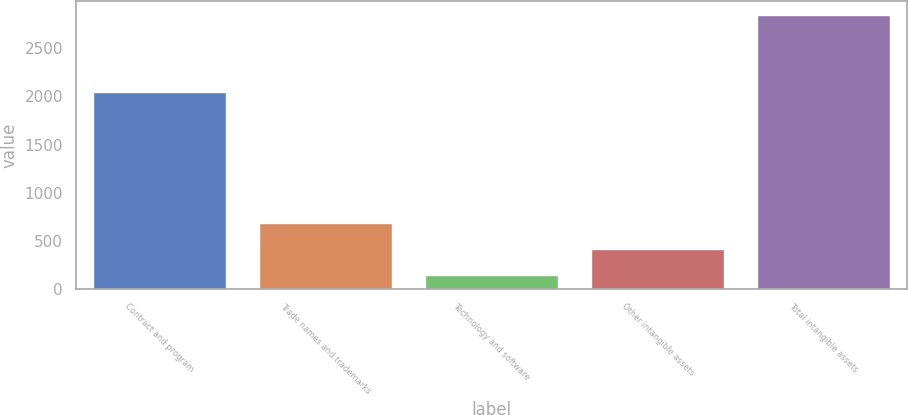Convert chart. <chart><loc_0><loc_0><loc_500><loc_500><bar_chart><fcel>Contract and program<fcel>Trade names and trademarks<fcel>Technology and software<fcel>Other intangible assets<fcel>Total intangible assets<nl><fcel>2042<fcel>680.8<fcel>140<fcel>410.4<fcel>2844<nl></chart> 